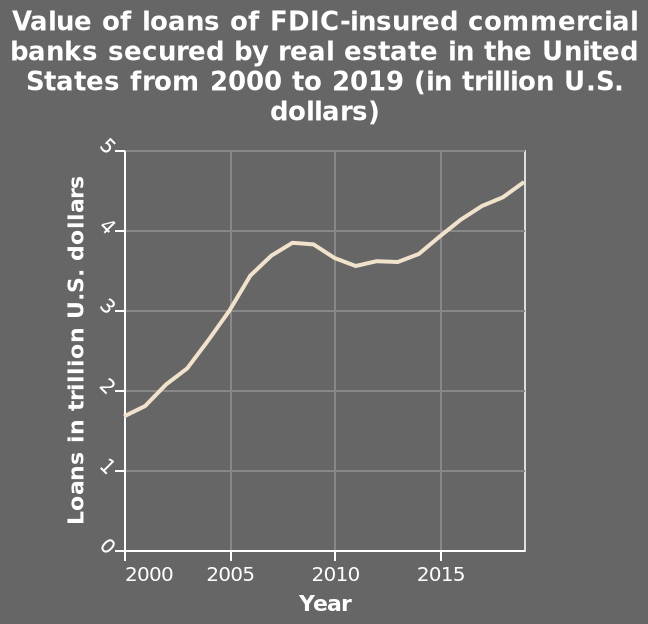<image>
What is the range of the y-axis? The range of the y-axis is from 0 to 5 trillion U.S. dollars. 